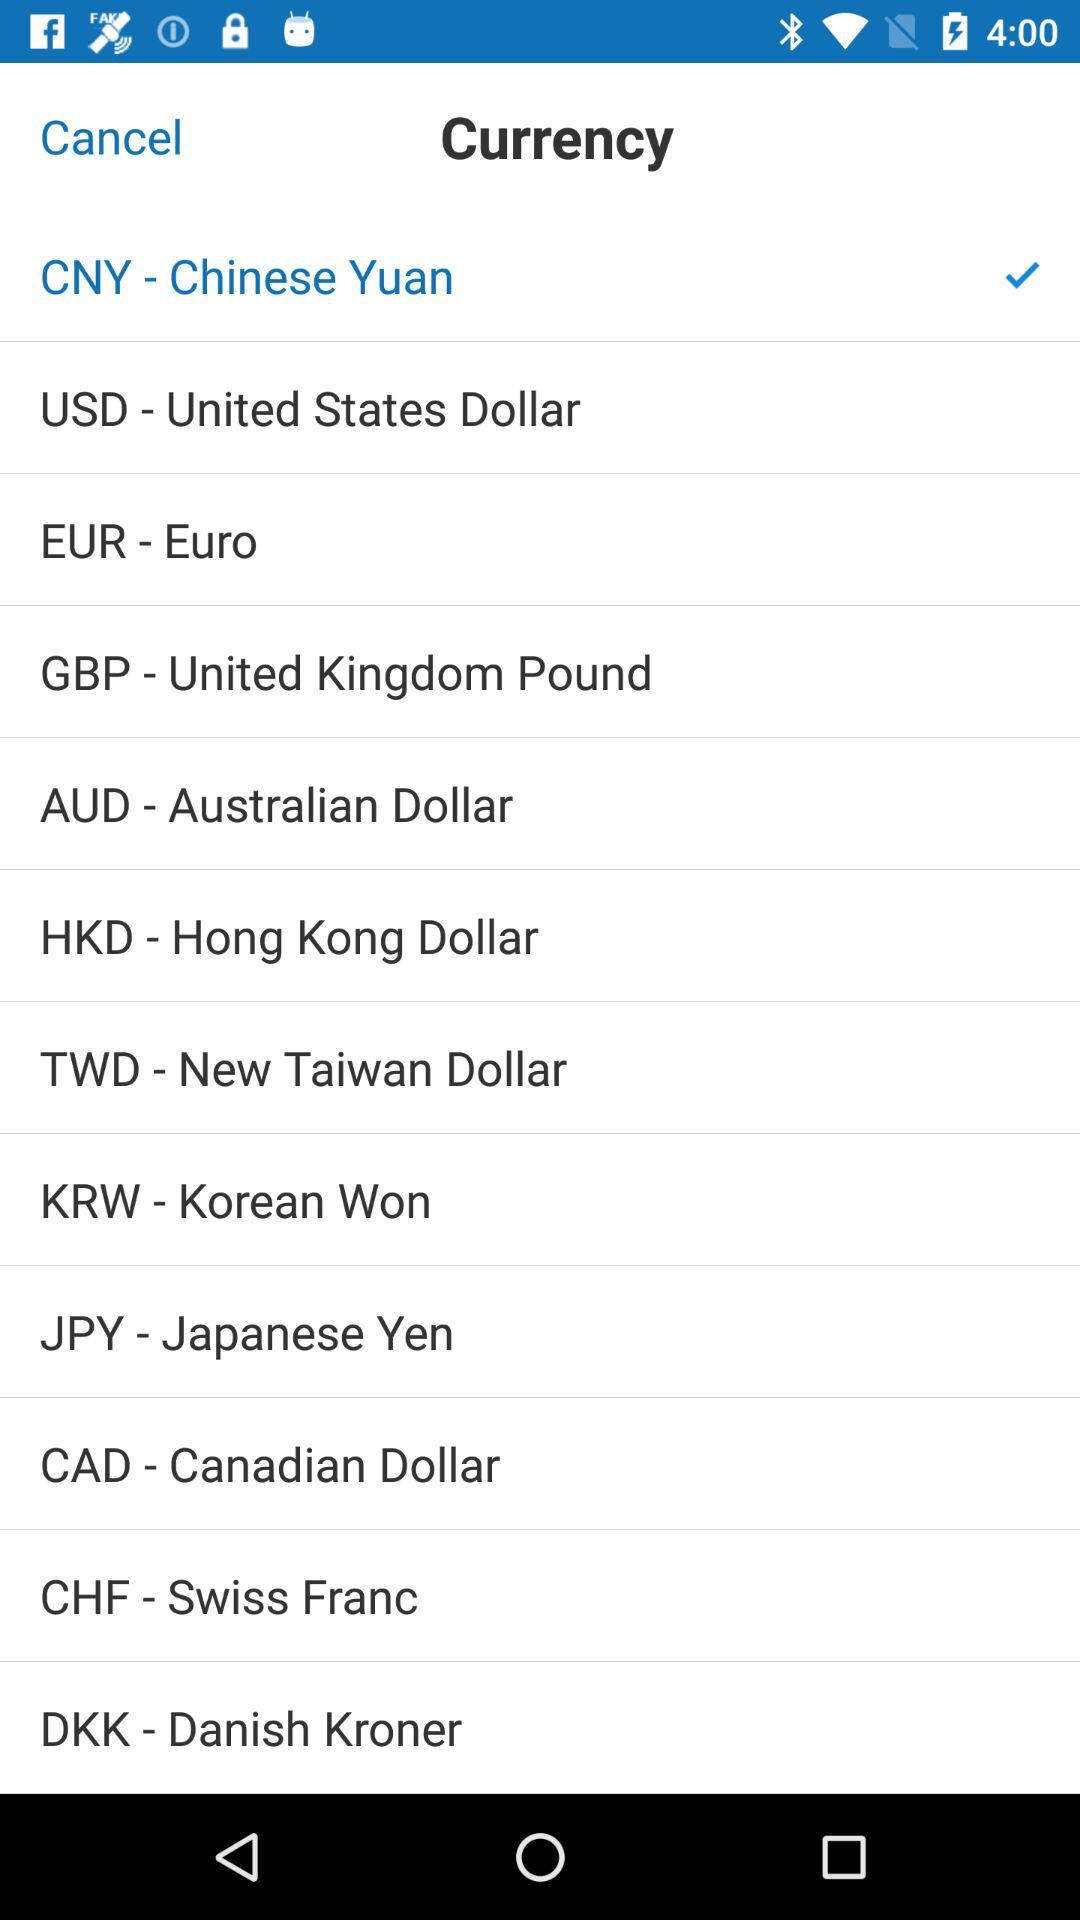Is EUR-Euro selected or not?
When the provided information is insufficient, respond with <no answer>. <no answer> 